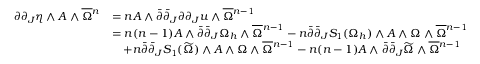<formula> <loc_0><loc_0><loc_500><loc_500>\begin{array} { r l } { \partial \partial _ { J } \eta \wedge A \wedge \overline { \Omega ^ { n } } & { = n A \wedge \bar { \partial } \bar { \partial } _ { J } \partial \partial _ { J } u \wedge \overline { \Omega ^ { n - 1 } } \\ & { = n ( n - 1 ) A \wedge \bar { \partial } \bar { \partial } _ { J } \Omega _ { h } \wedge \overline { \Omega ^ { n - 1 } - n \bar { \partial } \bar { \partial } _ { J } S _ { 1 } ( \Omega _ { h } ) \wedge A \wedge \Omega \wedge \overline { \Omega ^ { n - 1 } } \\ & { \quad + n \bar { \partial } \bar { \partial } _ { J } S _ { 1 } ( \widetilde { \Omega } ) \wedge A \wedge \Omega \wedge \overline { \Omega ^ { n - 1 } - n ( n - 1 ) A \wedge \bar { \partial } \bar { \partial } _ { J } \widetilde { \Omega } \wedge \overline { \Omega ^ { n - 1 } } \end{array}</formula> 